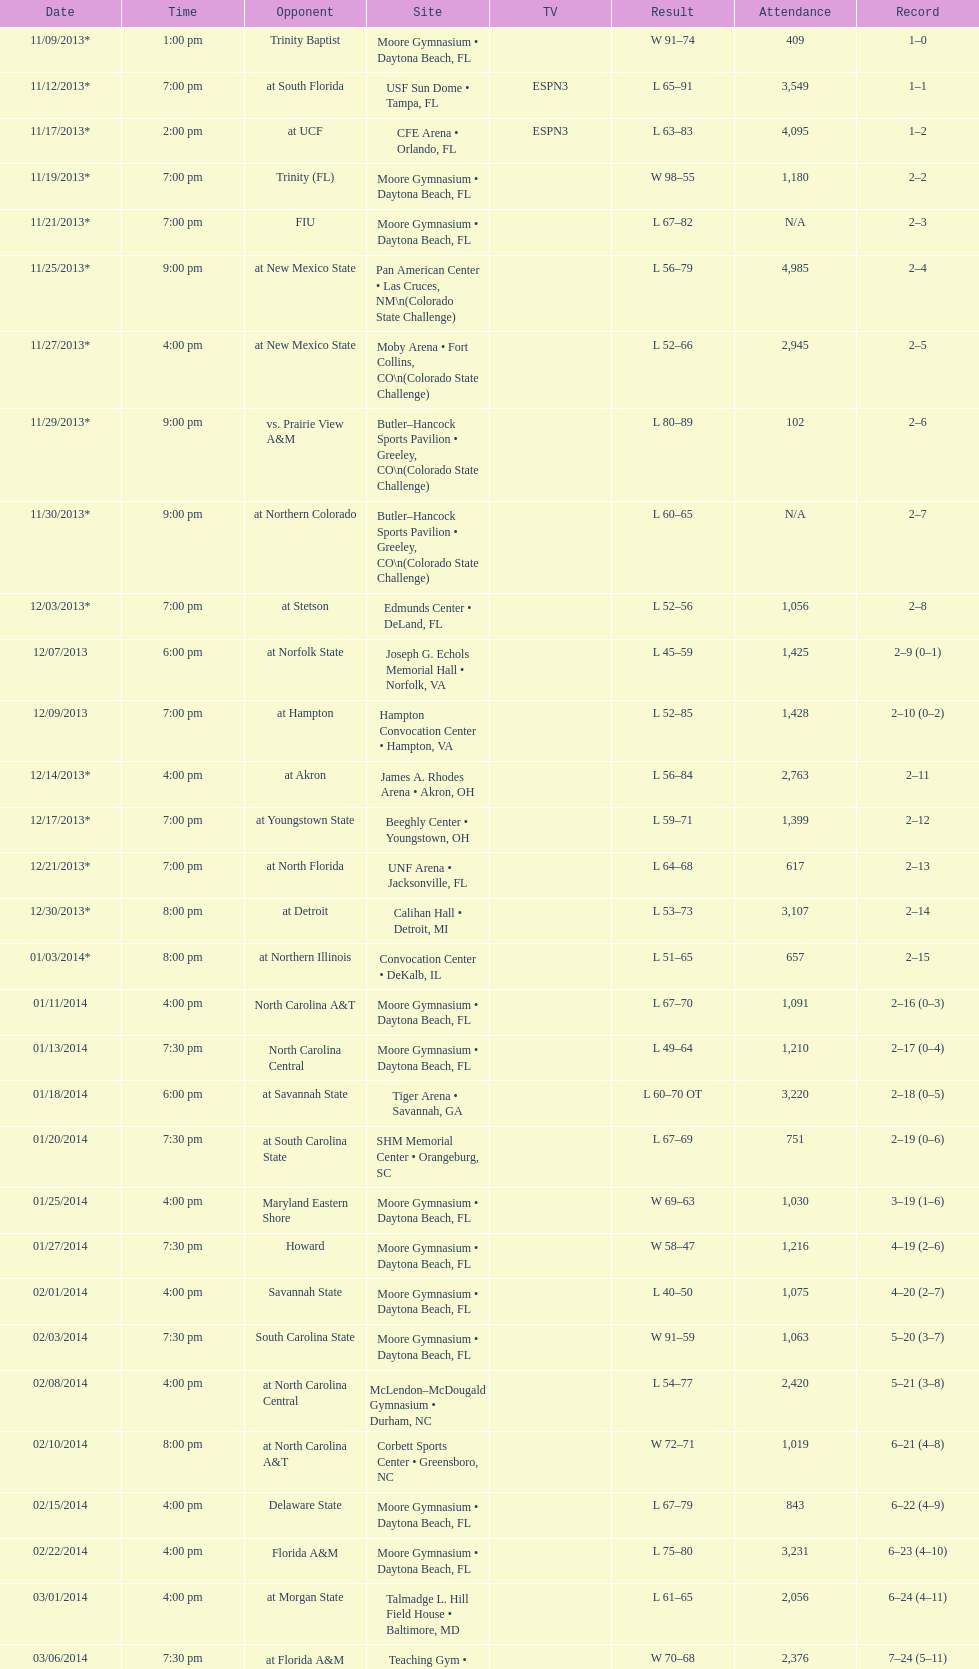How many games had more than 1,500 in attendance? 12. 